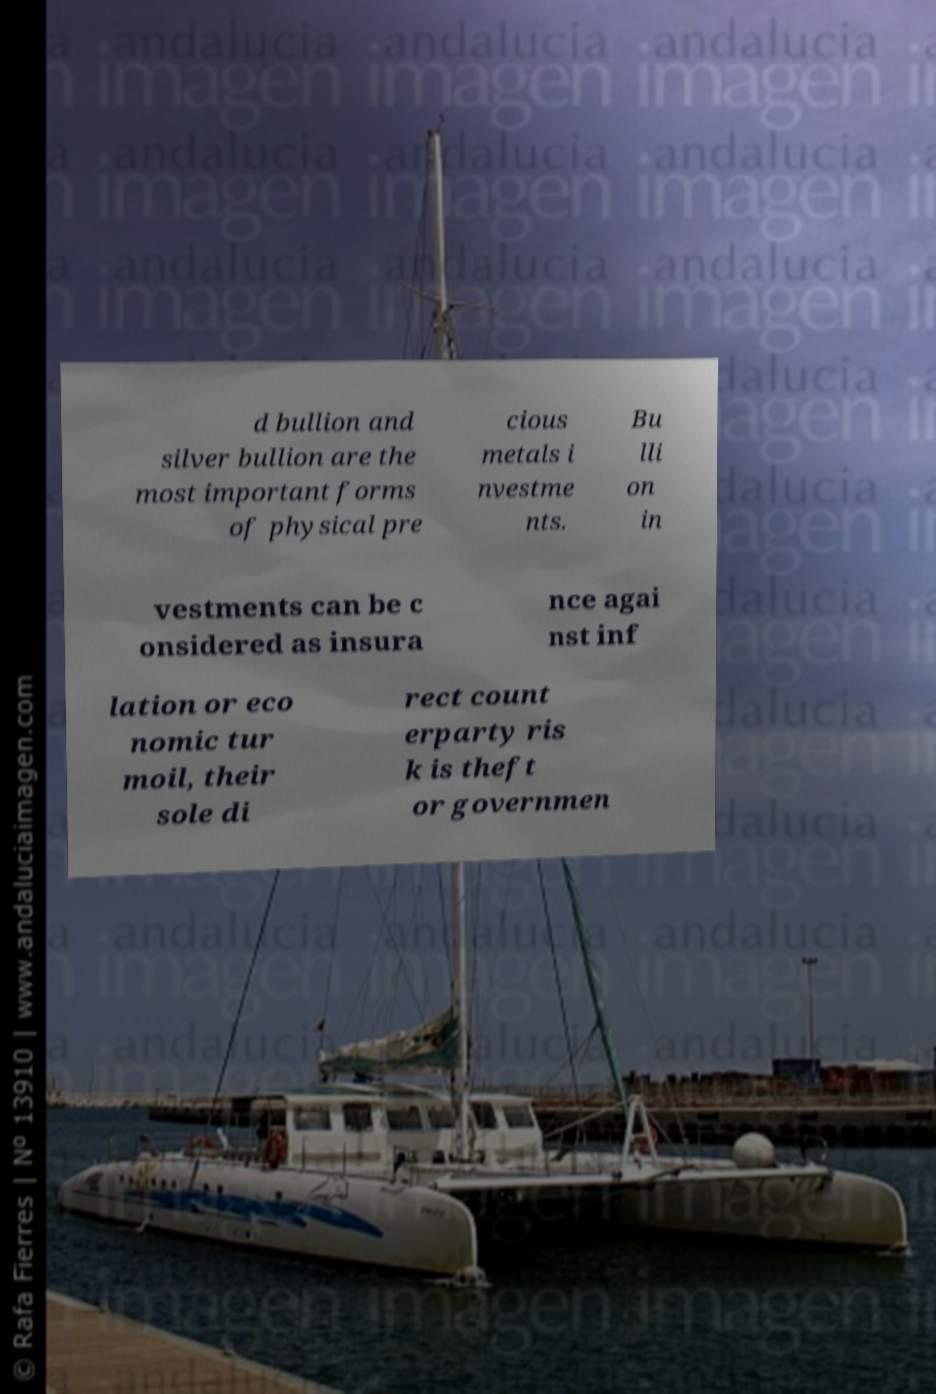Could you extract and type out the text from this image? d bullion and silver bullion are the most important forms of physical pre cious metals i nvestme nts. Bu lli on in vestments can be c onsidered as insura nce agai nst inf lation or eco nomic tur moil, their sole di rect count erparty ris k is theft or governmen 